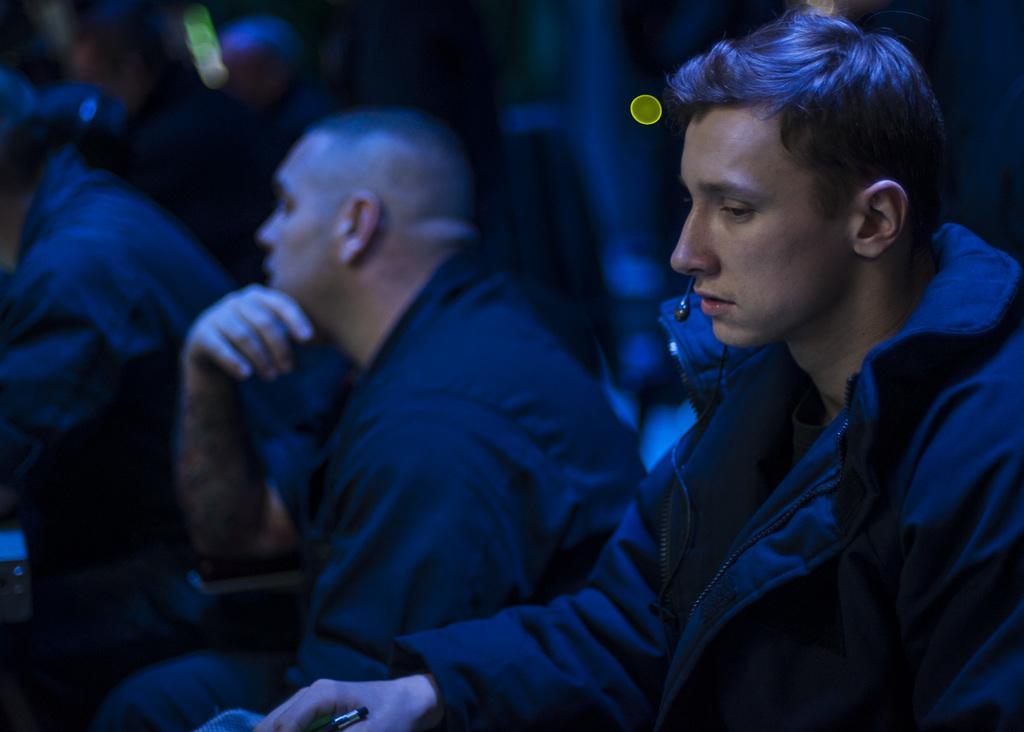In one or two sentences, can you explain what this image depicts? In this image we can see few people sitting and a person is holding an object and dark background. 